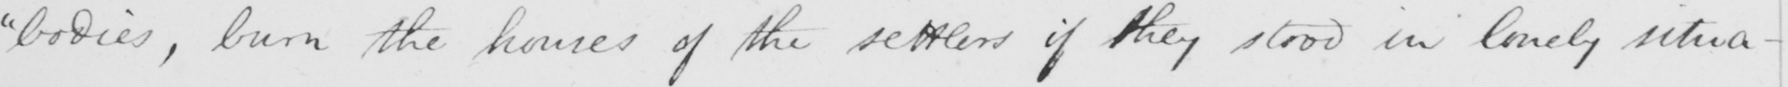Can you tell me what this handwritten text says? "bodies, burn the homes of the settlers if they stood in lonely situa- 